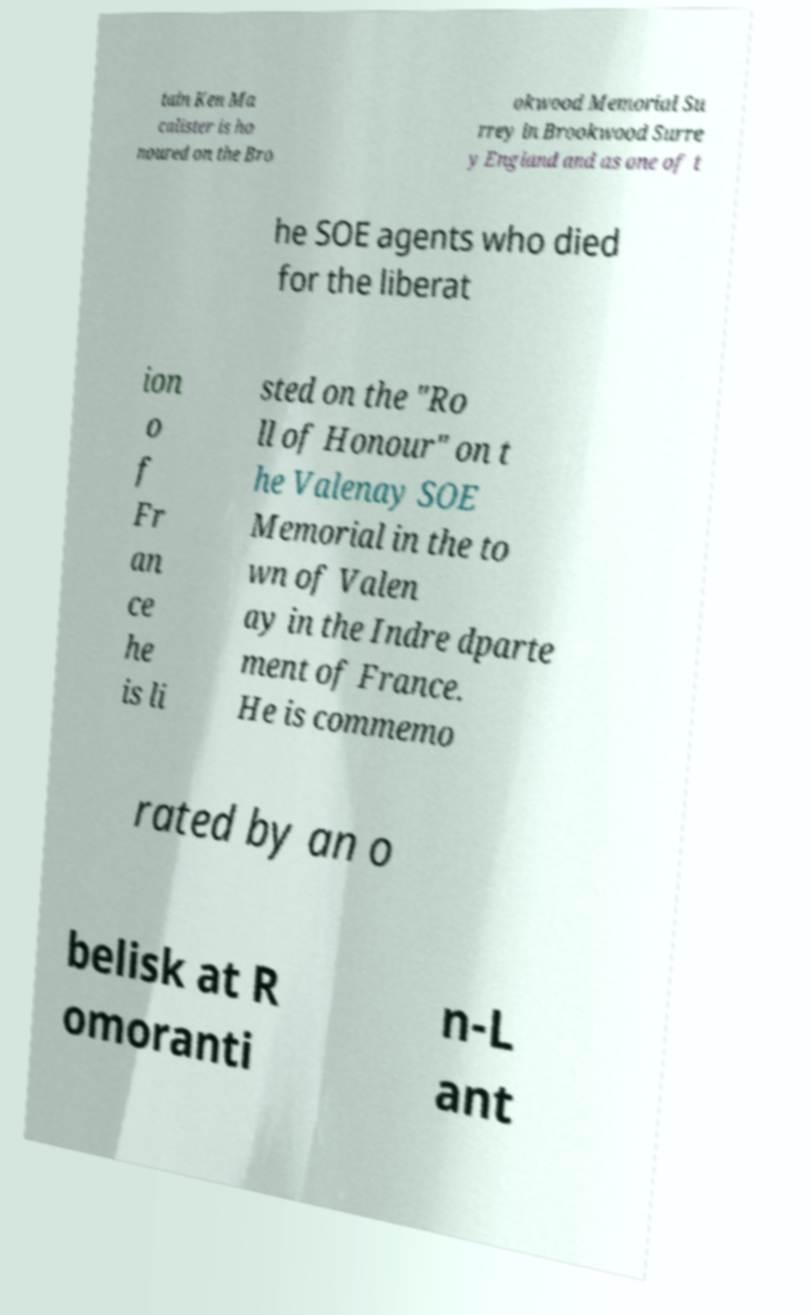Can you read and provide the text displayed in the image?This photo seems to have some interesting text. Can you extract and type it out for me? tain Ken Ma calister is ho noured on the Bro okwood Memorial Su rrey in Brookwood Surre y England and as one of t he SOE agents who died for the liberat ion o f Fr an ce he is li sted on the "Ro ll of Honour" on t he Valenay SOE Memorial in the to wn of Valen ay in the Indre dparte ment of France. He is commemo rated by an o belisk at R omoranti n-L ant 